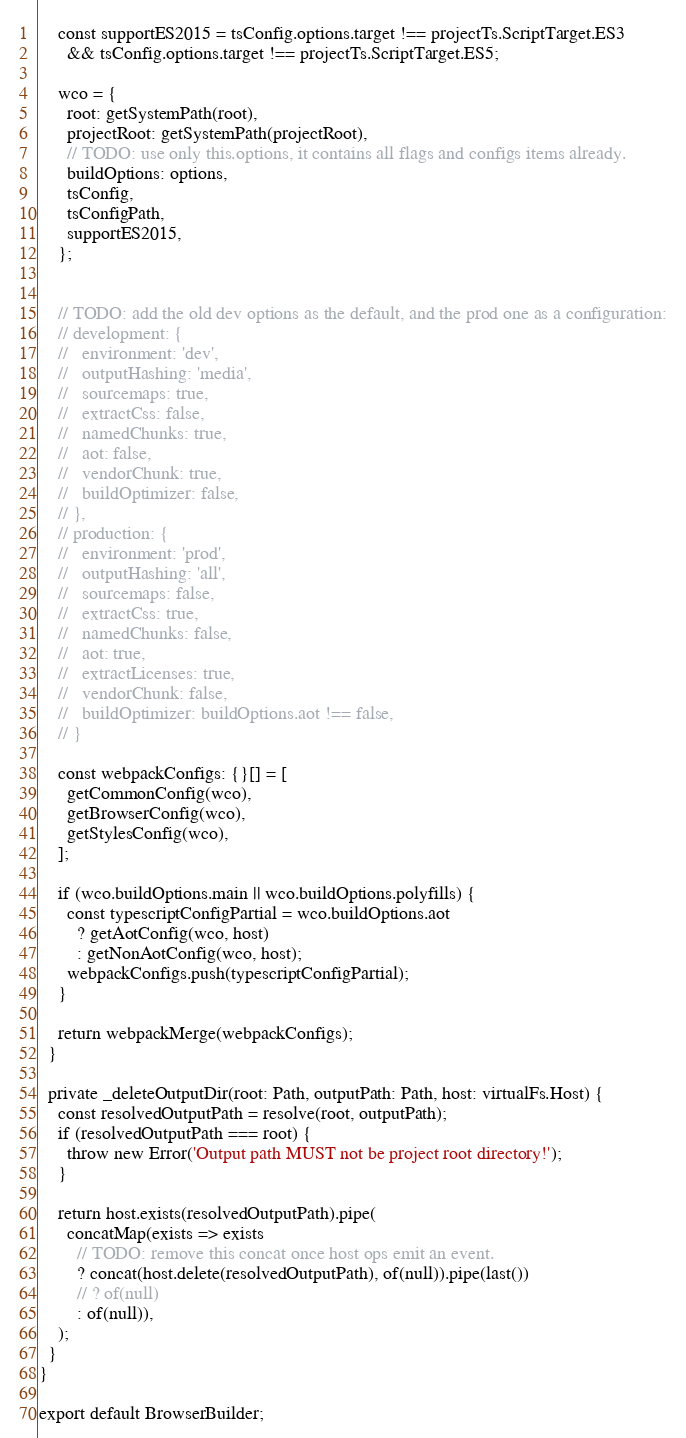Convert code to text. <code><loc_0><loc_0><loc_500><loc_500><_TypeScript_>    const supportES2015 = tsConfig.options.target !== projectTs.ScriptTarget.ES3
      && tsConfig.options.target !== projectTs.ScriptTarget.ES5;

    wco = {
      root: getSystemPath(root),
      projectRoot: getSystemPath(projectRoot),
      // TODO: use only this.options, it contains all flags and configs items already.
      buildOptions: options,
      tsConfig,
      tsConfigPath,
      supportES2015,
    };


    // TODO: add the old dev options as the default, and the prod one as a configuration:
    // development: {
    //   environment: 'dev',
    //   outputHashing: 'media',
    //   sourcemaps: true,
    //   extractCss: false,
    //   namedChunks: true,
    //   aot: false,
    //   vendorChunk: true,
    //   buildOptimizer: false,
    // },
    // production: {
    //   environment: 'prod',
    //   outputHashing: 'all',
    //   sourcemaps: false,
    //   extractCss: true,
    //   namedChunks: false,
    //   aot: true,
    //   extractLicenses: true,
    //   vendorChunk: false,
    //   buildOptimizer: buildOptions.aot !== false,
    // }

    const webpackConfigs: {}[] = [
      getCommonConfig(wco),
      getBrowserConfig(wco),
      getStylesConfig(wco),
    ];

    if (wco.buildOptions.main || wco.buildOptions.polyfills) {
      const typescriptConfigPartial = wco.buildOptions.aot
        ? getAotConfig(wco, host)
        : getNonAotConfig(wco, host);
      webpackConfigs.push(typescriptConfigPartial);
    }

    return webpackMerge(webpackConfigs);
  }

  private _deleteOutputDir(root: Path, outputPath: Path, host: virtualFs.Host) {
    const resolvedOutputPath = resolve(root, outputPath);
    if (resolvedOutputPath === root) {
      throw new Error('Output path MUST not be project root directory!');
    }

    return host.exists(resolvedOutputPath).pipe(
      concatMap(exists => exists
        // TODO: remove this concat once host ops emit an event.
        ? concat(host.delete(resolvedOutputPath), of(null)).pipe(last())
        // ? of(null)
        : of(null)),
    );
  }
}

export default BrowserBuilder;
</code> 